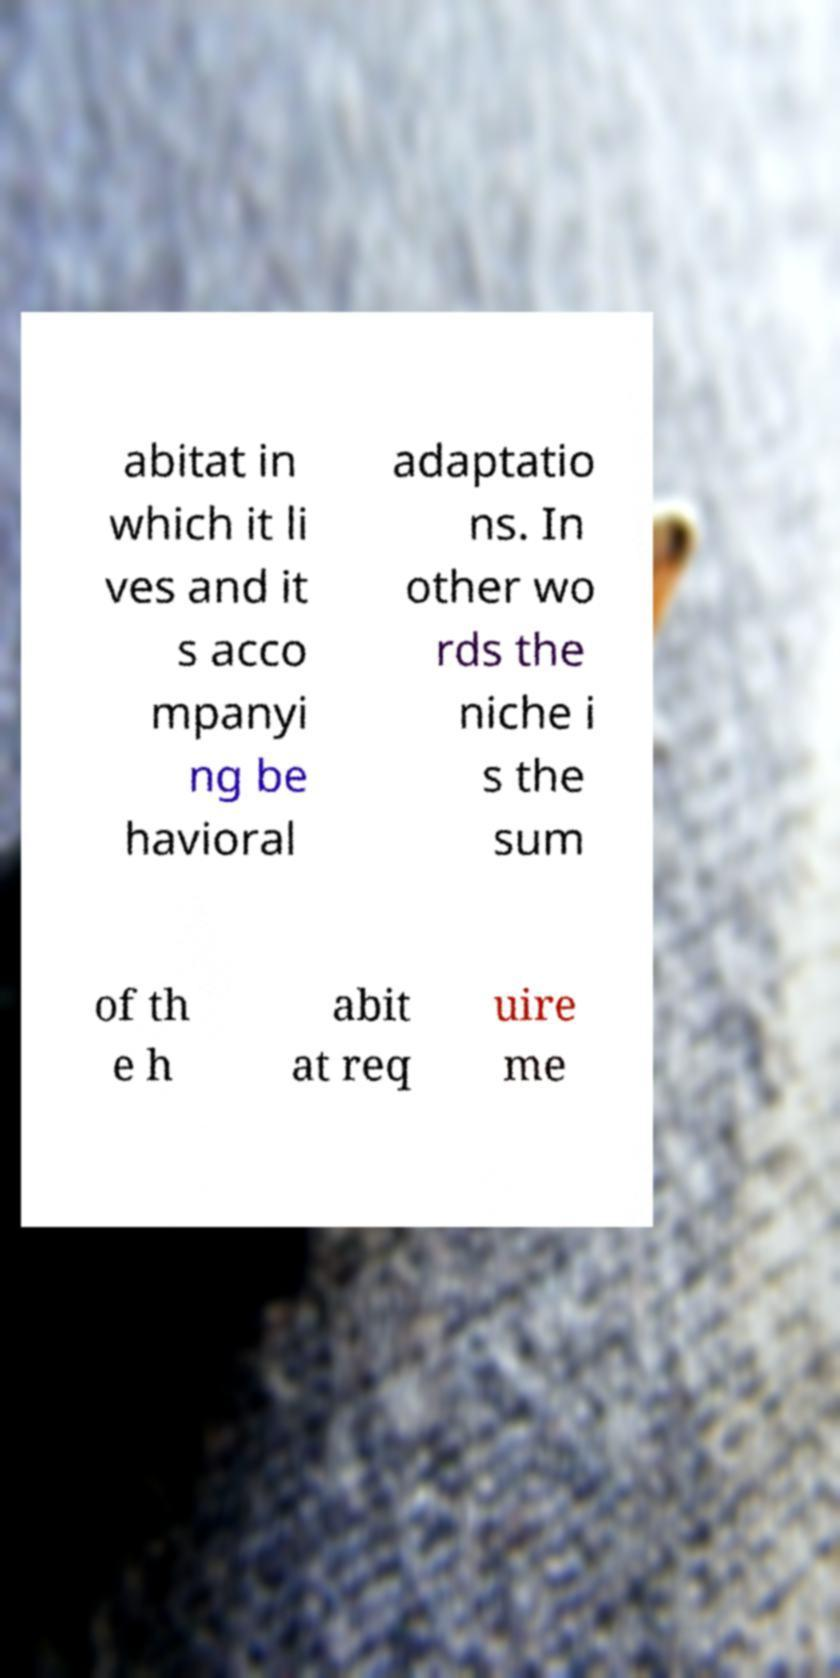Please identify and transcribe the text found in this image. abitat in which it li ves and it s acco mpanyi ng be havioral adaptatio ns. In other wo rds the niche i s the sum of th e h abit at req uire me 